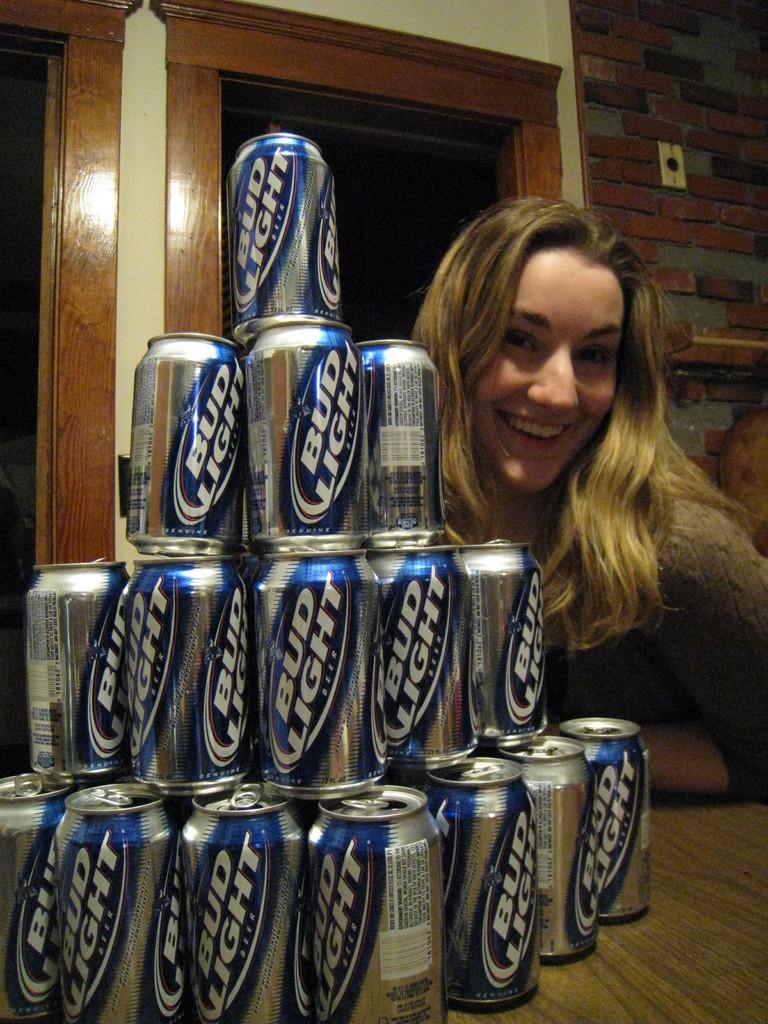Is bud light a beer or carbonated drink?
Keep it short and to the point. Beer. 